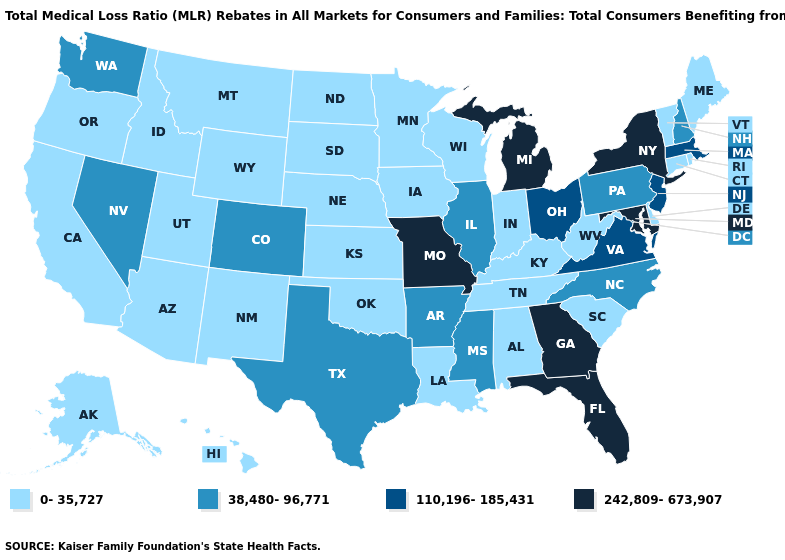Does Arkansas have a lower value than New York?
Short answer required. Yes. What is the highest value in states that border New Mexico?
Answer briefly. 38,480-96,771. Name the states that have a value in the range 242,809-673,907?
Keep it brief. Florida, Georgia, Maryland, Michigan, Missouri, New York. Name the states that have a value in the range 0-35,727?
Write a very short answer. Alabama, Alaska, Arizona, California, Connecticut, Delaware, Hawaii, Idaho, Indiana, Iowa, Kansas, Kentucky, Louisiana, Maine, Minnesota, Montana, Nebraska, New Mexico, North Dakota, Oklahoma, Oregon, Rhode Island, South Carolina, South Dakota, Tennessee, Utah, Vermont, West Virginia, Wisconsin, Wyoming. What is the value of Indiana?
Give a very brief answer. 0-35,727. What is the lowest value in the West?
Give a very brief answer. 0-35,727. What is the value of Alaska?
Short answer required. 0-35,727. Name the states that have a value in the range 110,196-185,431?
Write a very short answer. Massachusetts, New Jersey, Ohio, Virginia. Name the states that have a value in the range 110,196-185,431?
Quick response, please. Massachusetts, New Jersey, Ohio, Virginia. Is the legend a continuous bar?
Concise answer only. No. What is the lowest value in states that border Kentucky?
Answer briefly. 0-35,727. Which states have the lowest value in the Northeast?
Answer briefly. Connecticut, Maine, Rhode Island, Vermont. How many symbols are there in the legend?
Short answer required. 4. Is the legend a continuous bar?
Be succinct. No. Does the map have missing data?
Write a very short answer. No. 